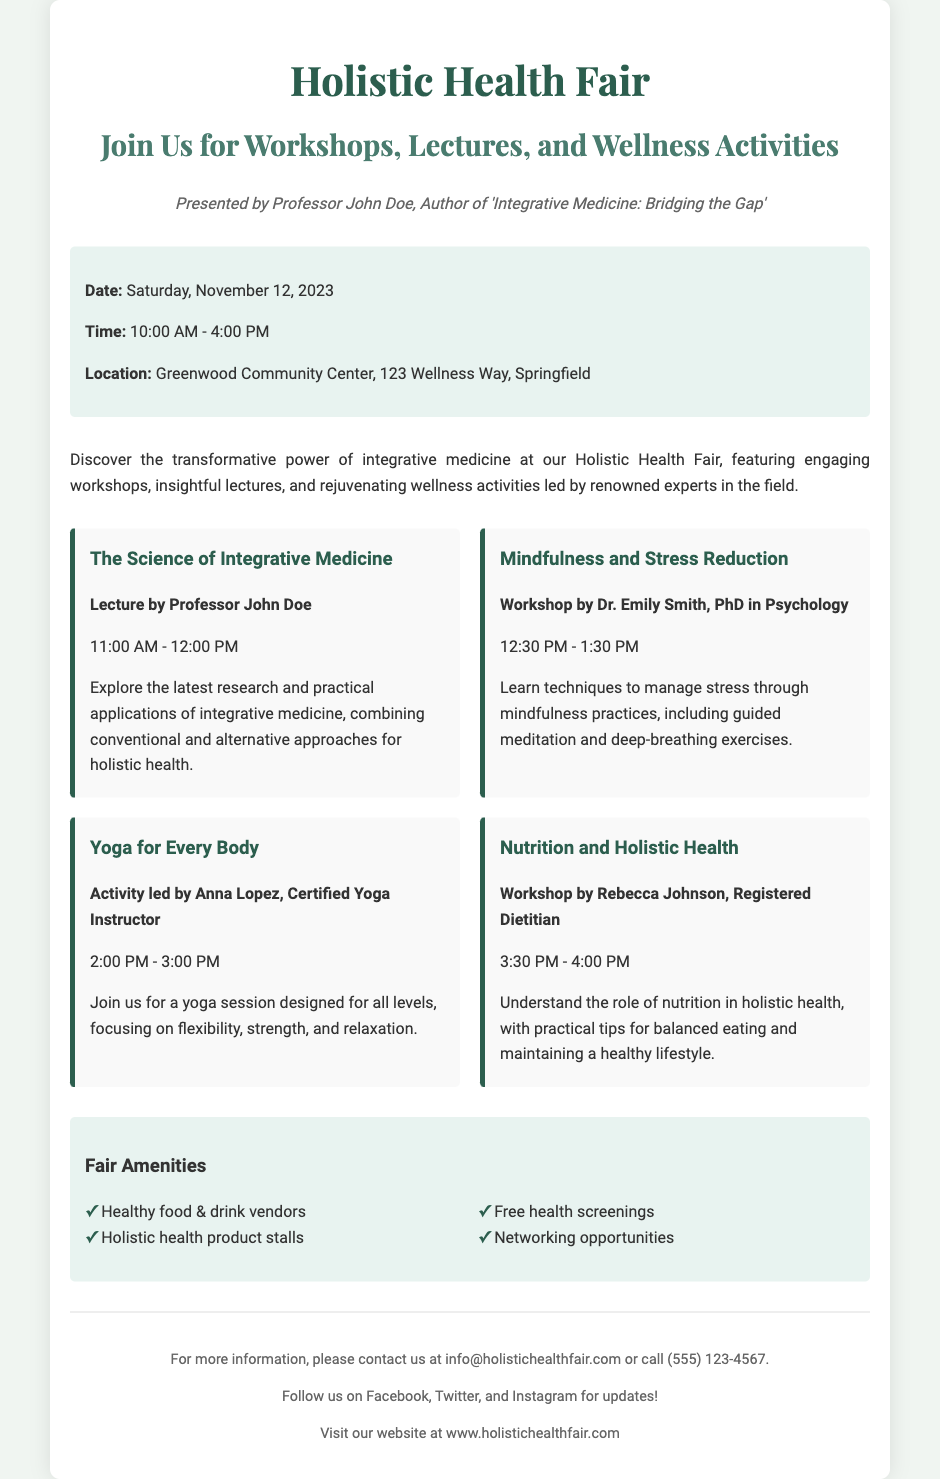What is the title of the event? The title of the event is prominently displayed at the top of the flyer.
Answer: Holistic Health Fair Who is presenting the fair? The flyer mentions the presenter and their credentials as part of the header.
Answer: Professor John Doe What date is the Holistic Health Fair scheduled? The date is specified in the event details section of the flyer.
Answer: Saturday, November 12, 2023 What time does the fair start? The starting time is listed in the event details section.
Answer: 10:00 AM What is one topic covered during a workshop? The highlights section lists various workshops along with their topics.
Answer: Mindfulness and Stress Reduction Who is leading the yoga activity? The name of the person leading the yoga session is mentioned in the highlights section.
Answer: Anna Lopez What type of nutrition professional will be present? The flyer indicates the profession of the person conducting the nutrition workshop.
Answer: Registered Dietitian What is one amenity mentioned for the fair? The amenities section lists features available at the fair.
Answer: Free health screenings At what location is the event taking place? The location of the event is provided in the event details.
Answer: Greenwood Community Center, 123 Wellness Way, Springfield 